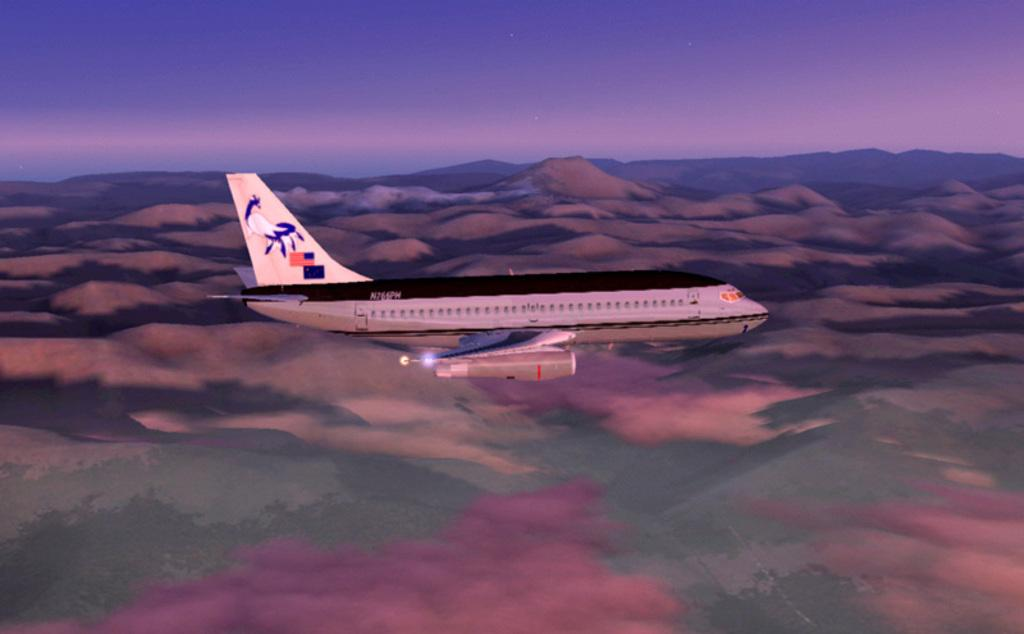What is the main subject of the image? The main subject of the image is an airplane. What is the airplane doing in the image? The airplane is flying in the air. What type of landscape can be seen in the image? There are hills visible on the land in the image. What part of the natural environment is visible in the image? The sky is visible in the image. What direction is the territory moving in the image? There is no territory present in the image, and therefore no direction of movement can be observed. 